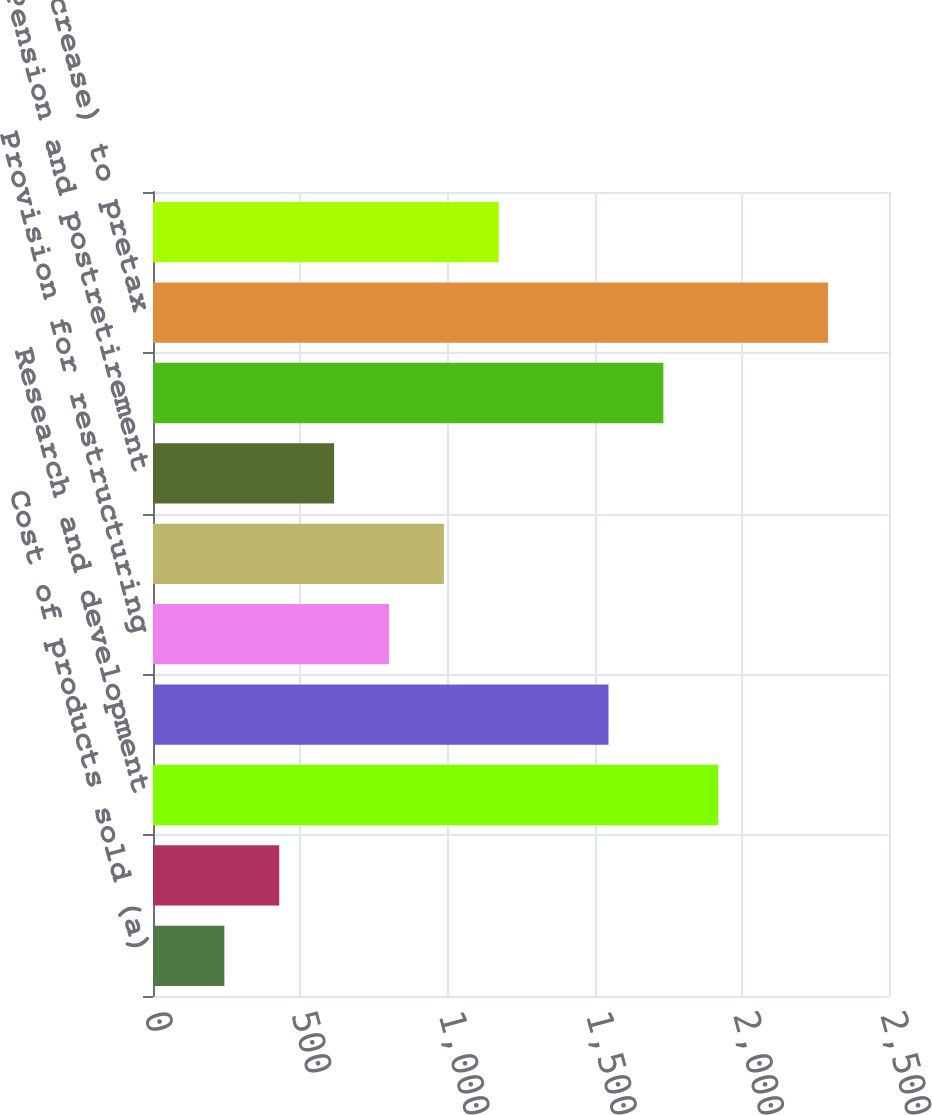<chart> <loc_0><loc_0><loc_500><loc_500><bar_chart><fcel>Cost of products sold (a)<fcel>Site exit costs<fcel>Research and development<fcel>Loss/(gain) on equity<fcel>Provision for restructuring<fcel>Divestiture gains<fcel>Pension and postretirement<fcel>Other income (net)<fcel>Increase/(decrease) to pretax<fcel>Income taxes on items above<nl><fcel>242.4<fcel>428.8<fcel>1920<fcel>1547.2<fcel>801.6<fcel>988<fcel>615.2<fcel>1733.6<fcel>2292.8<fcel>1174.4<nl></chart> 